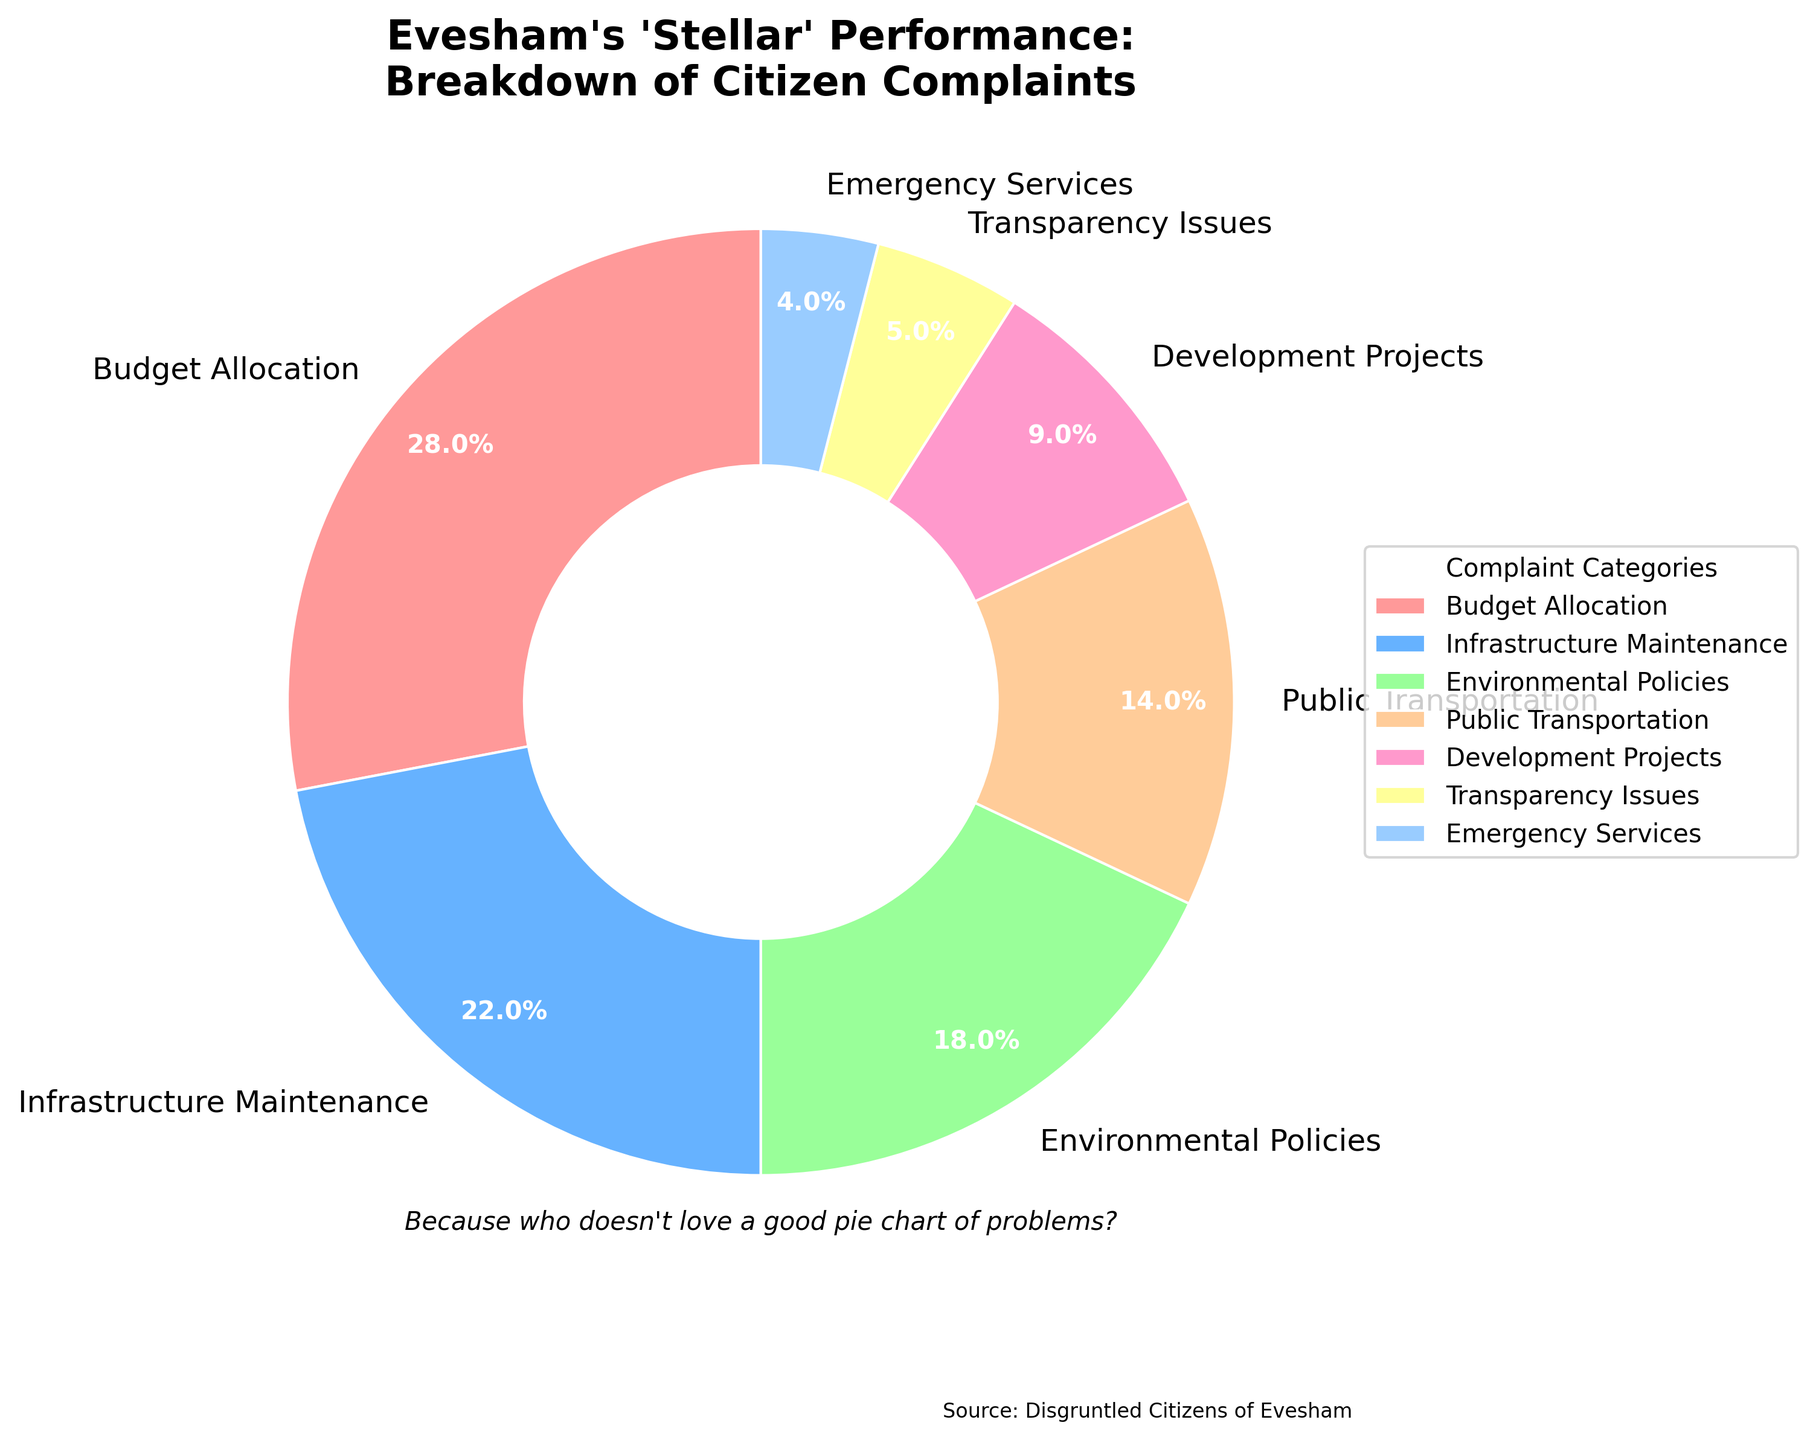what percentage of total complaints are about budget allocation and infrastructure maintenance combined? Combine both percentages for budget allocation (28%) and infrastructure maintenance (22%), giving 28% + 22% = 50%
Answer: 50% Which complaint category has the least percentage? Identify the category with the smallest value in the list, which is Emergency Services at 4%
Answer: Emergency Services How many more complaints are there about public transportation than emergency services? Subtract the percentage of Emergency Services complaints (4%) from Public Transportation complaints (14%): 14% - 4% = 10%
Answer: 10% Which is the second largest complaint category? Identify the second largest percentage after Budget Allocation (28%), which is Infrastructure Maintenance at 22%
Answer: Infrastructure Maintenance What is the visual color associated with complaints about environmental policies? Identify the color corresponding to the Environmental Policies section of the pie chart, which is green
Answer: Green Are complaints about development projects more or less than 10% of the total? Compare the percentage of Development Projects complaints (9%) to 10%; 9% is less than 10%
Answer: Less What is the combined percentage for categories with the smallest percentage? Add percentages of Emergency Services (4%) and Transparency Issues (5%): 4% + 5% = 9%
Answer: 9% Which complaint has a larger percentage: Environmental Policies or Public Transportation? Compare the percentages: Environmental Policies (18%) and Public Transportation (14%); 18% is greater than 14%
Answer: Environmental Policies What is the percentage difference between Budget Allocation and Transparency Issues categories? Subtract the percentage of Transparency Issues (5%) from Budget Allocation (28%): 28% - 5% = 23%
Answer: 23% What percentage of total complaints are not related to Budget Allocation or Infrastructure Maintenance? Subtract the combined percentage of Budget Allocation and Infrastructure Maintenance (50%) from 100%: 100% - 50% = 50%
Answer: 50% 